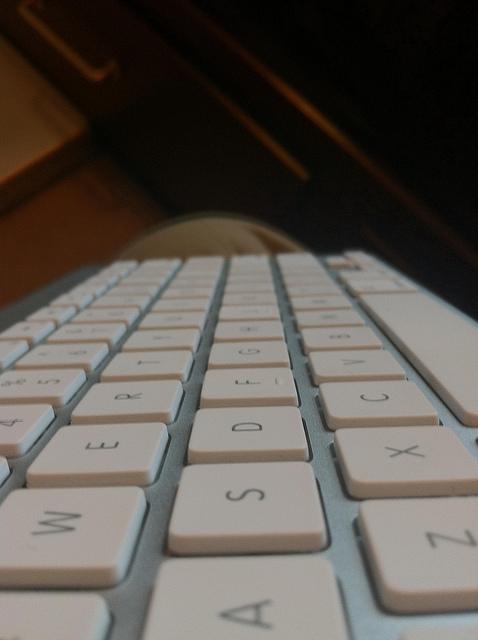Can you form the word "weds" from the letters that can be read on this keyboard?
Write a very short answer. Yes. What color is the keyboard?
Answer briefly. White. What side of the keyboard is the camera?
Quick response, please. Left. 